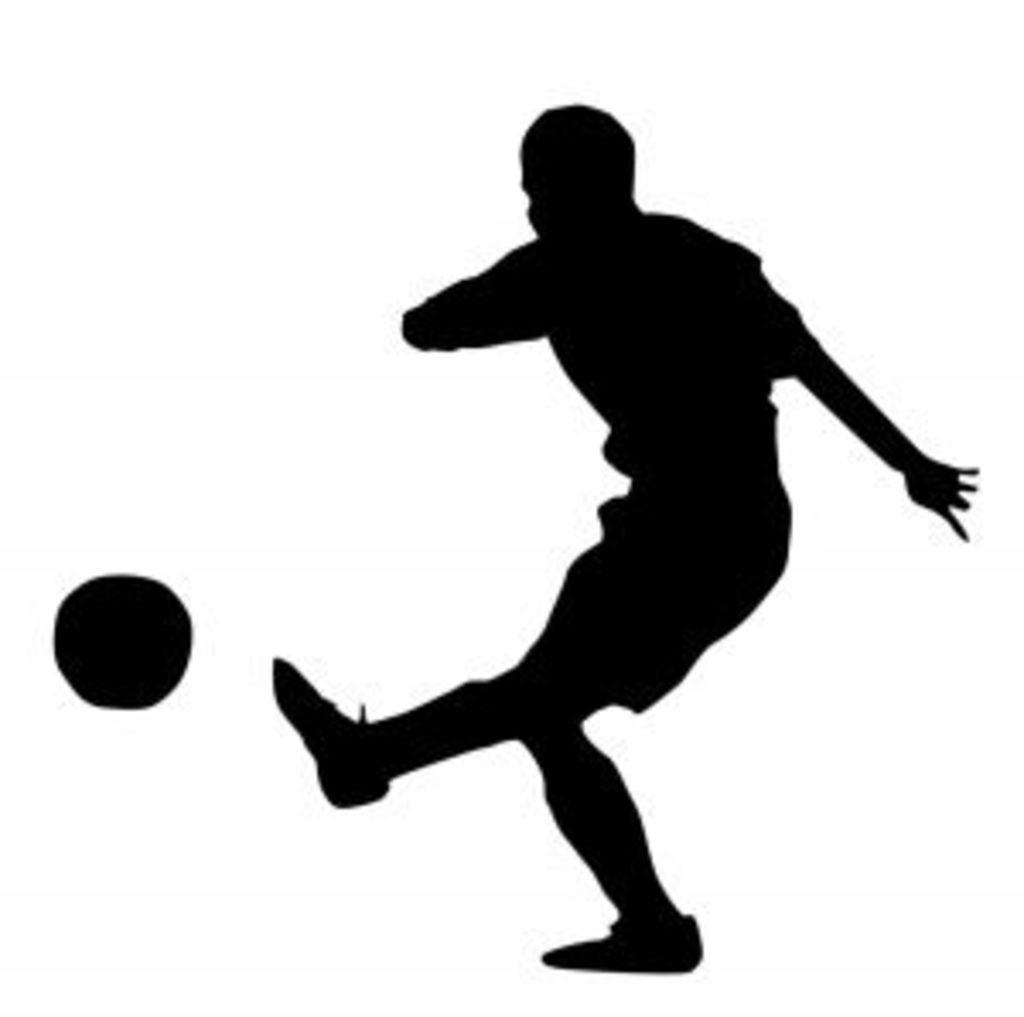Who or what is present in the image? There is a person in the image. What can be seen in the background of the image? There is a wall in the image. What type of thread is being used by the person in the image? There is no thread visible in the image, as the person is the only subject mentioned in the facts. 